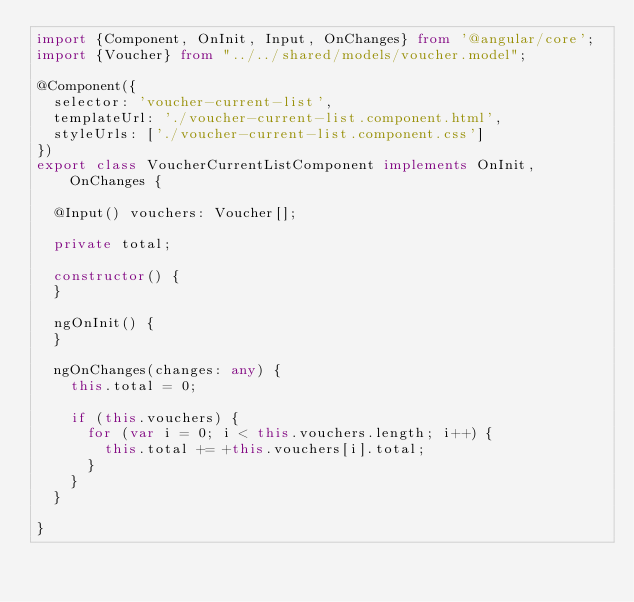<code> <loc_0><loc_0><loc_500><loc_500><_TypeScript_>import {Component, OnInit, Input, OnChanges} from '@angular/core';
import {Voucher} from "../../shared/models/voucher.model";

@Component({
  selector: 'voucher-current-list',
  templateUrl: './voucher-current-list.component.html',
  styleUrls: ['./voucher-current-list.component.css']
})
export class VoucherCurrentListComponent implements OnInit, OnChanges {

  @Input() vouchers: Voucher[];

  private total;

  constructor() {
  }

  ngOnInit() {
  }

  ngOnChanges(changes: any) {
    this.total = 0;

    if (this.vouchers) {
      for (var i = 0; i < this.vouchers.length; i++) {
        this.total += +this.vouchers[i].total;
      }
    }
  }

}
</code> 